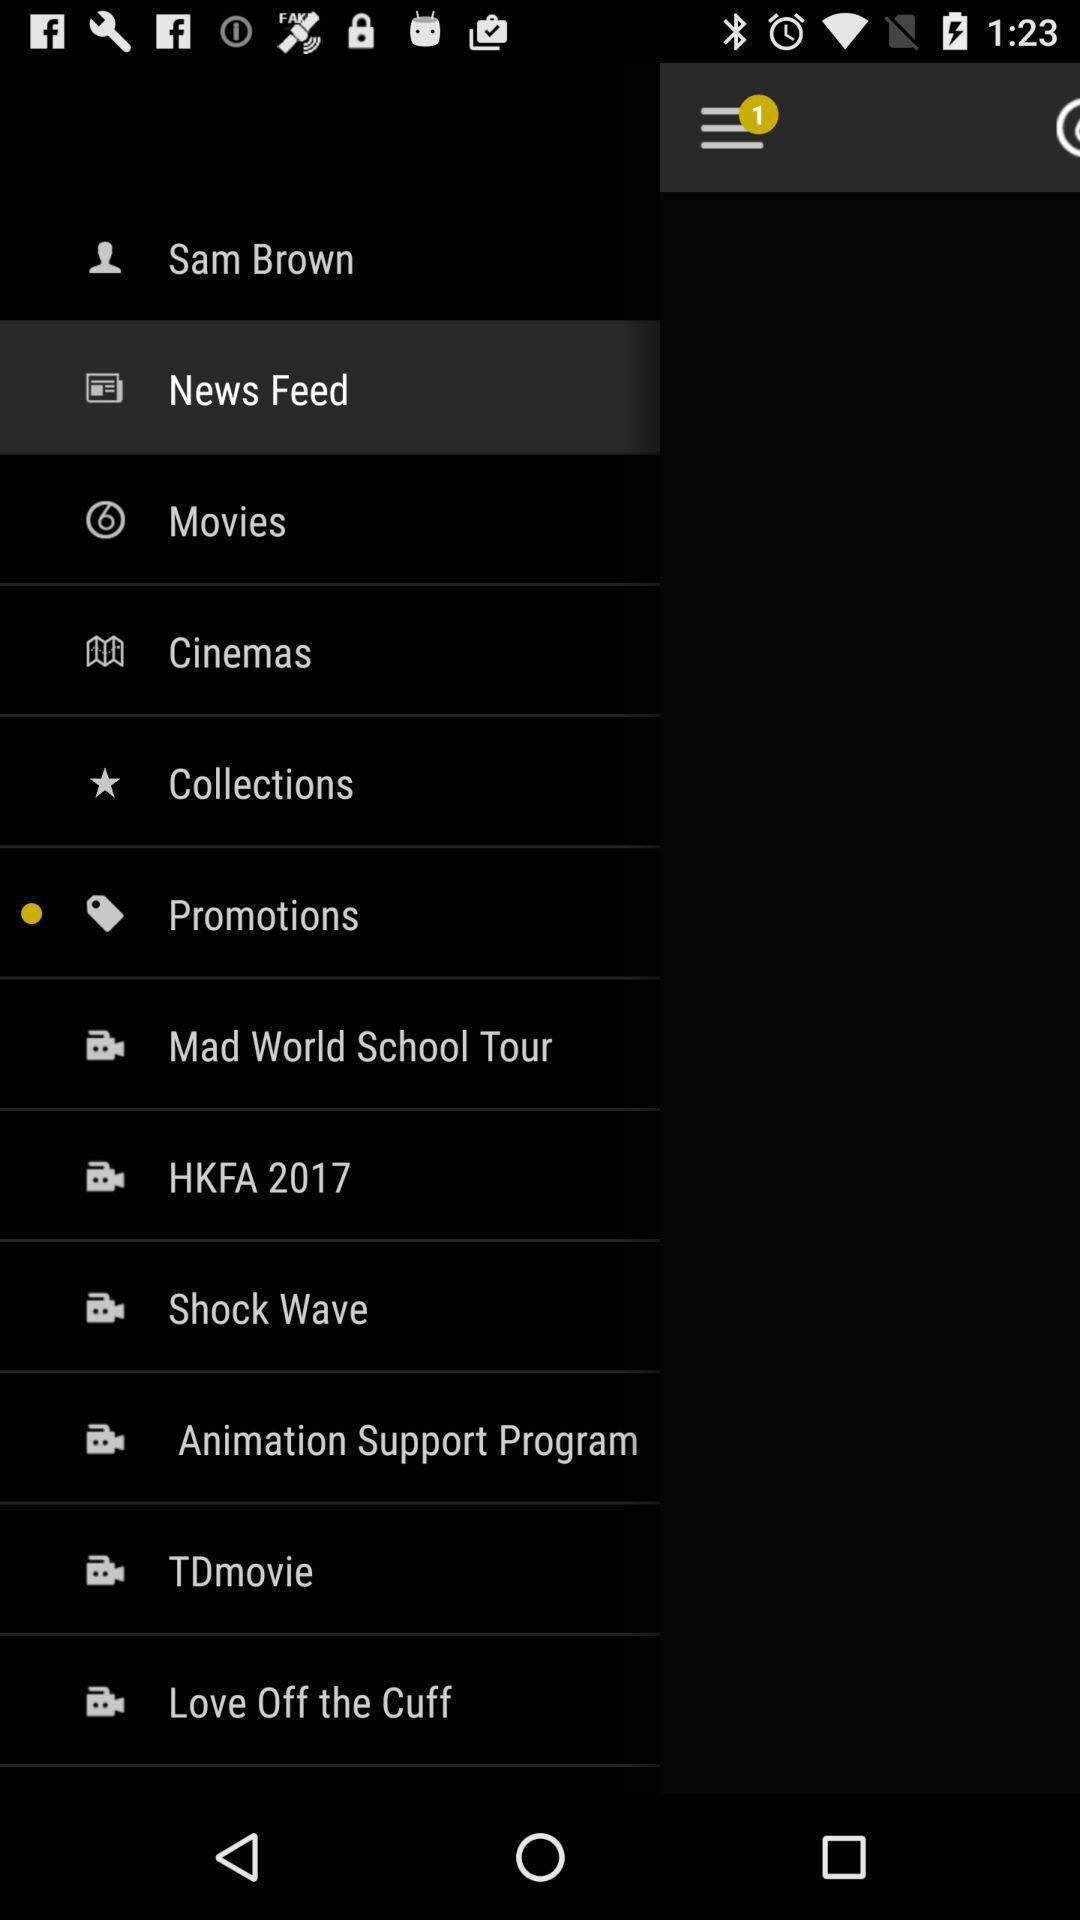What is the user name? The user name is Sam Brown. 